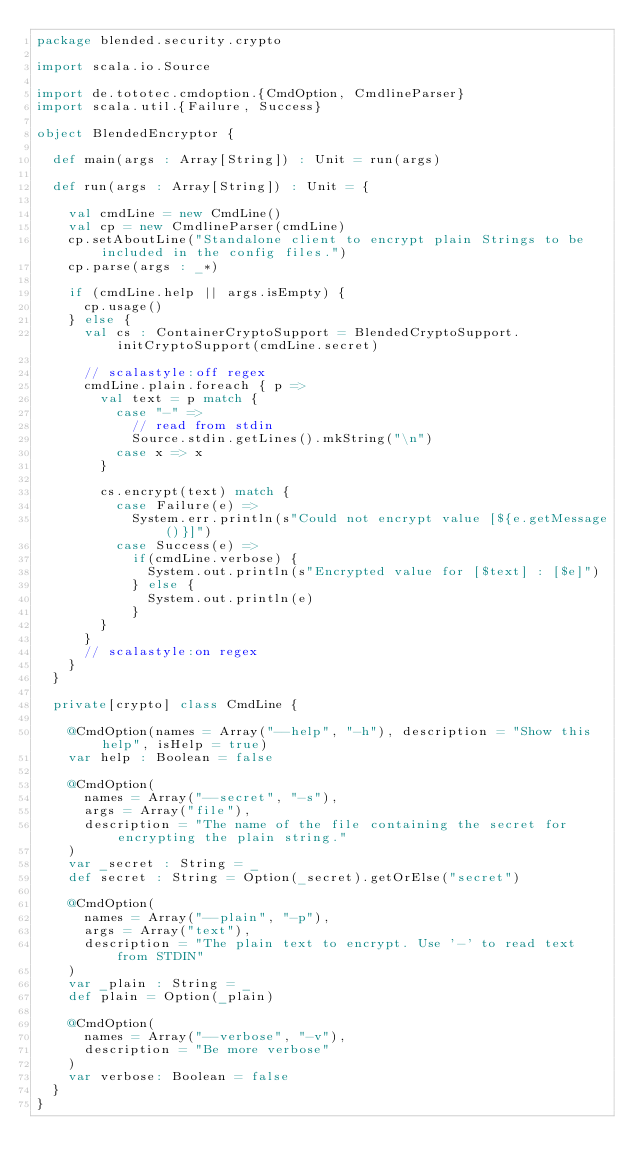<code> <loc_0><loc_0><loc_500><loc_500><_Scala_>package blended.security.crypto

import scala.io.Source

import de.tototec.cmdoption.{CmdOption, CmdlineParser}
import scala.util.{Failure, Success}

object BlendedEncryptor {

  def main(args : Array[String]) : Unit = run(args)

  def run(args : Array[String]) : Unit = {

    val cmdLine = new CmdLine()
    val cp = new CmdlineParser(cmdLine)
    cp.setAboutLine("Standalone client to encrypt plain Strings to be included in the config files.")
    cp.parse(args : _*)

    if (cmdLine.help || args.isEmpty) {
      cp.usage()
    } else {
      val cs : ContainerCryptoSupport = BlendedCryptoSupport.initCryptoSupport(cmdLine.secret)

      // scalastyle:off regex
      cmdLine.plain.foreach { p =>
        val text = p match {
          case "-" =>
            // read from stdin
            Source.stdin.getLines().mkString("\n")
          case x => x
        }

        cs.encrypt(text) match {
          case Failure(e) =>
            System.err.println(s"Could not encrypt value [${e.getMessage()}]")
          case Success(e) =>
            if(cmdLine.verbose) {
              System.out.println(s"Encrypted value for [$text] : [$e]")
            } else {
              System.out.println(e)
            }
        }
      }
      // scalastyle:on regex
    }
  }

  private[crypto] class CmdLine {

    @CmdOption(names = Array("--help", "-h"), description = "Show this help", isHelp = true)
    var help : Boolean = false

    @CmdOption(
      names = Array("--secret", "-s"),
      args = Array("file"),
      description = "The name of the file containing the secret for encrypting the plain string."
    )
    var _secret : String = _
    def secret : String = Option(_secret).getOrElse("secret")

    @CmdOption(
      names = Array("--plain", "-p"),
      args = Array("text"),
      description = "The plain text to encrypt. Use '-' to read text from STDIN"
    )
    var _plain : String = _
    def plain = Option(_plain)

    @CmdOption(
      names = Array("--verbose", "-v"),
      description = "Be more verbose"
    )
    var verbose: Boolean = false
  }
}
</code> 